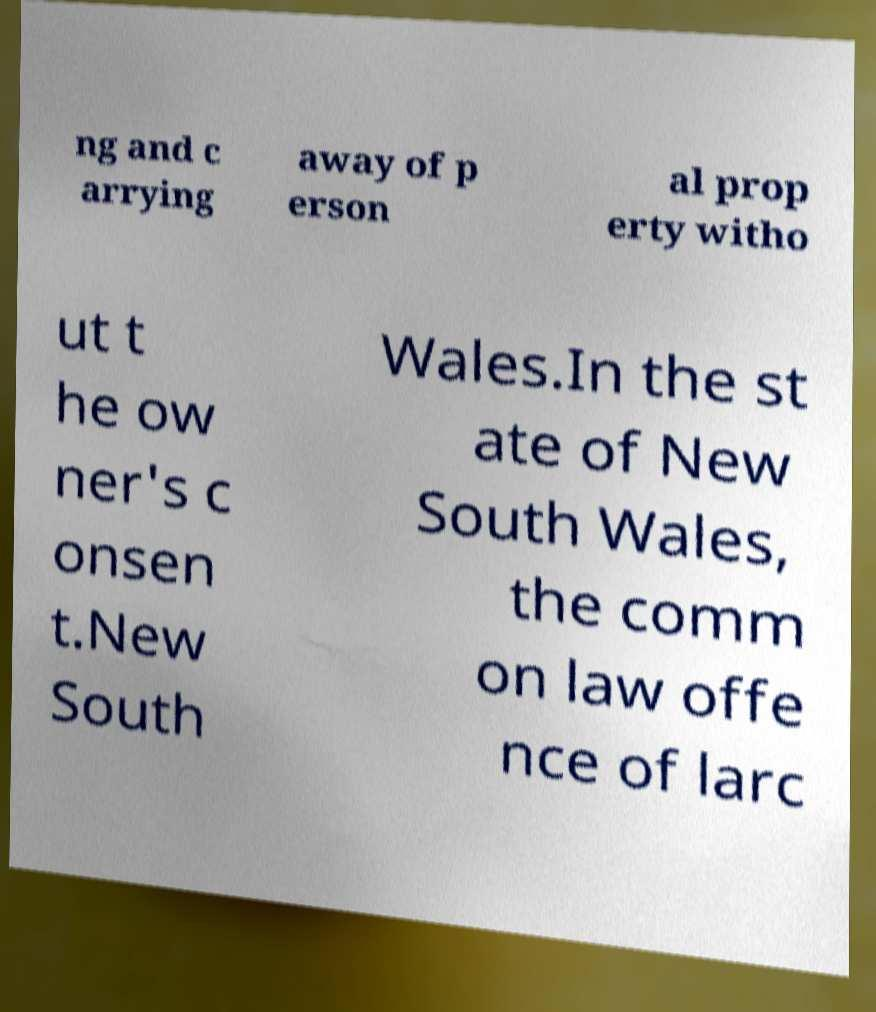Could you extract and type out the text from this image? ng and c arrying away of p erson al prop erty witho ut t he ow ner's c onsen t.New South Wales.In the st ate of New South Wales, the comm on law offe nce of larc 